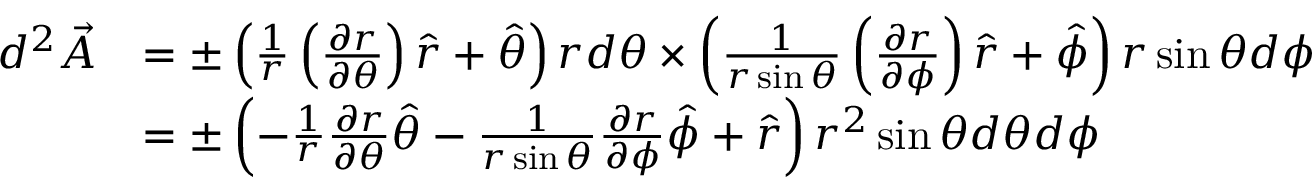<formula> <loc_0><loc_0><loc_500><loc_500>\begin{array} { r l } { d ^ { 2 } \vec { A } } & { = \pm \left ( \frac { 1 } { r } \left ( \frac { \partial r } { \partial \theta } \right ) \hat { r } + \hat { \theta } \right ) r d \theta \times \left ( \frac { 1 } r \sin \theta } \left ( \frac { \partial r } { \partial \phi } \right ) \hat { r } + \hat { \phi } \right ) r \sin \theta d \phi } \\ & { = \pm \left ( - \frac { 1 } { r } \frac { \partial r } { \partial \theta } \hat { \theta } - \frac { 1 } r \sin \theta } \frac { \partial r } { \partial \phi } \hat { \phi } + \hat { r } \right ) r ^ { 2 } \sin \theta d \theta d \phi } \end{array}</formula> 